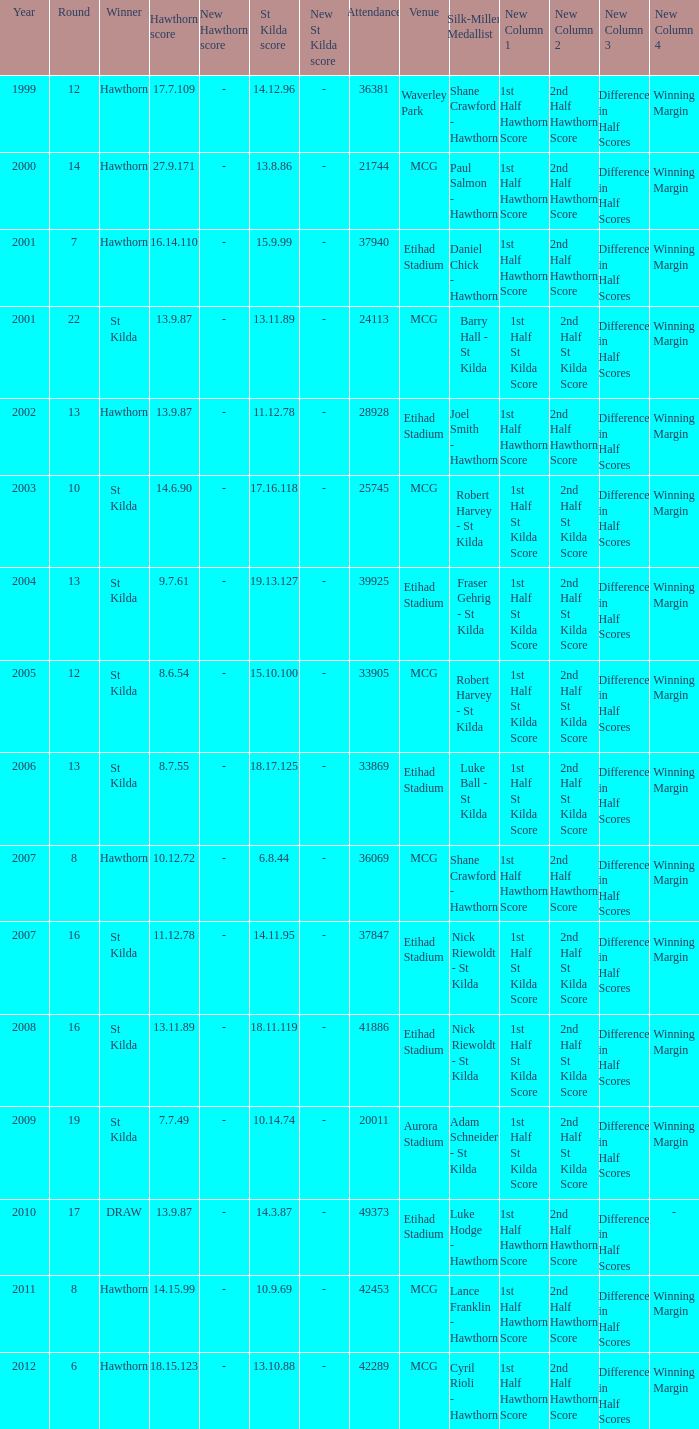What is the attendance when the hawthorn score is 18.15.123? 42289.0. 